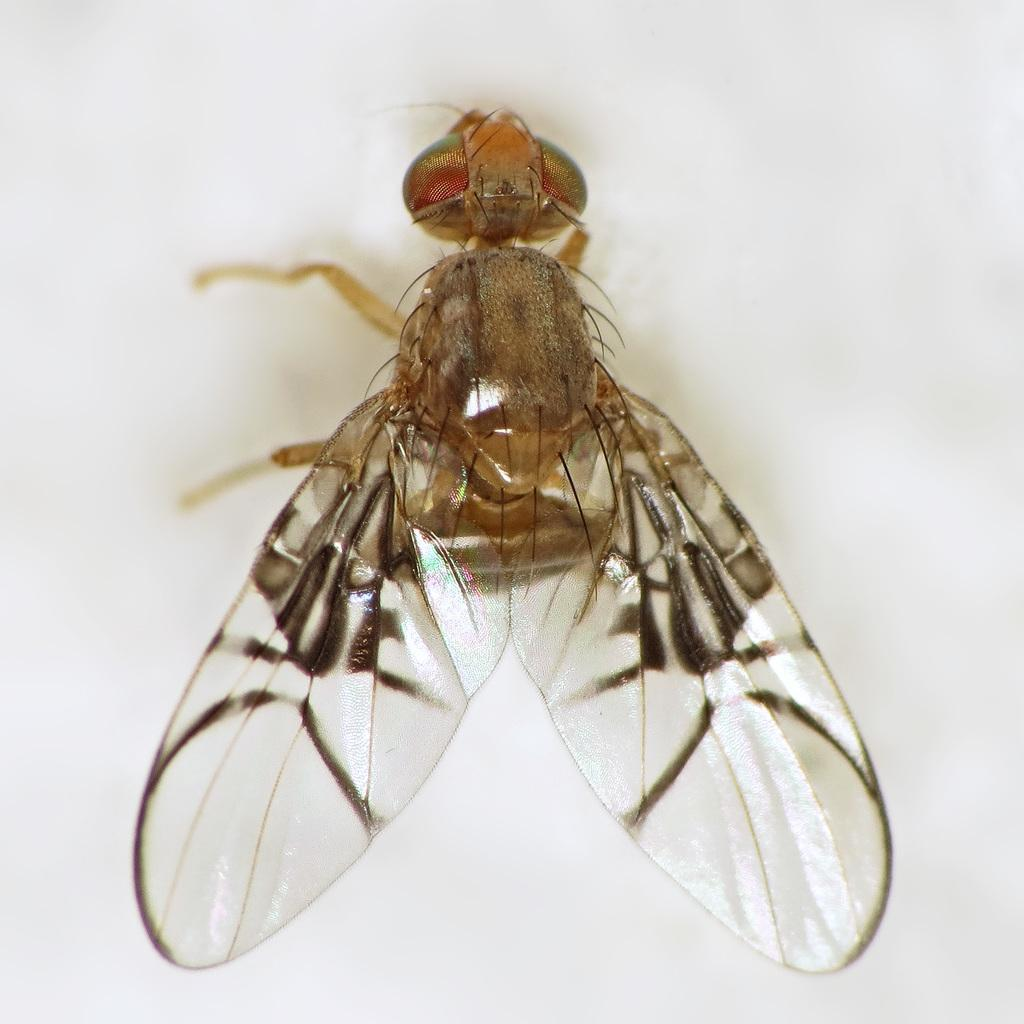What type of insect is in the picture? There is a housefly in the picture. What are the main features of the housefly? The housefly has wings, a head, and legs. What is the color of the surface the housefly is on? The housefly is placed on a white surface. What type of canvas is the woman using to soothe her throat in the image? There is no woman or canvas present in the image; it features a housefly on a white surface. 